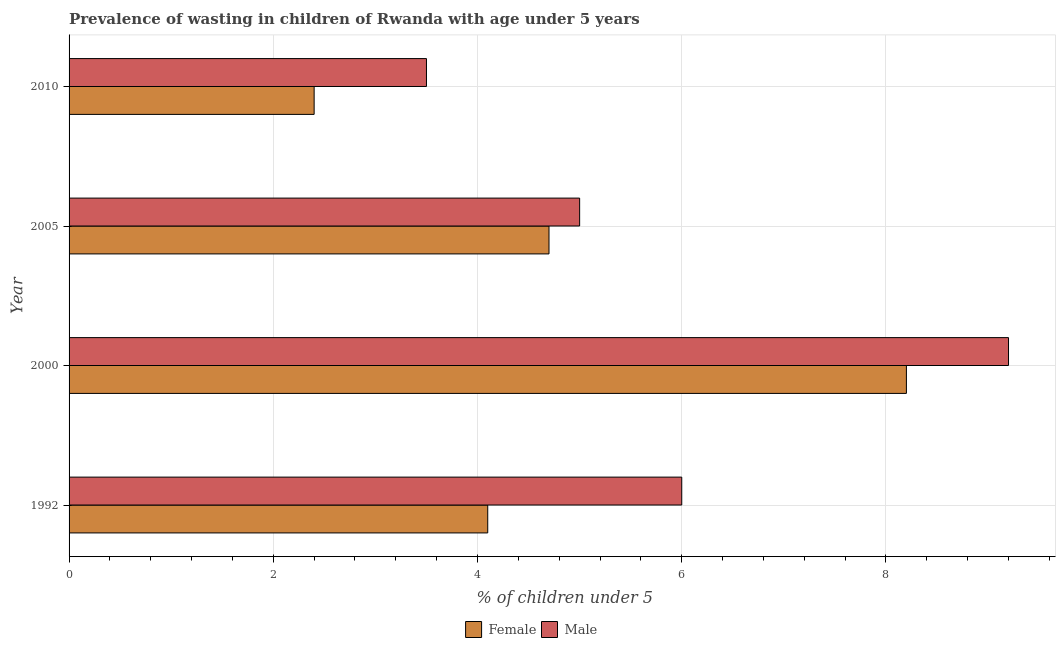How many groups of bars are there?
Your answer should be compact. 4. Are the number of bars on each tick of the Y-axis equal?
Offer a terse response. Yes. How many bars are there on the 1st tick from the top?
Give a very brief answer. 2. What is the percentage of undernourished female children in 2010?
Offer a terse response. 2.4. Across all years, what is the maximum percentage of undernourished female children?
Keep it short and to the point. 8.2. Across all years, what is the minimum percentage of undernourished male children?
Offer a terse response. 3.5. What is the total percentage of undernourished male children in the graph?
Offer a terse response. 23.7. What is the difference between the percentage of undernourished female children in 2005 and the percentage of undernourished male children in 1992?
Keep it short and to the point. -1.3. What is the average percentage of undernourished female children per year?
Offer a very short reply. 4.85. In how many years, is the percentage of undernourished male children greater than 7.6 %?
Your answer should be compact. 1. Is the percentage of undernourished female children in 1992 less than that in 2010?
Provide a short and direct response. No. Is the difference between the percentage of undernourished female children in 2000 and 2010 greater than the difference between the percentage of undernourished male children in 2000 and 2010?
Your answer should be compact. Yes. What is the difference between the highest and the second highest percentage of undernourished female children?
Provide a succinct answer. 3.5. What is the difference between the highest and the lowest percentage of undernourished female children?
Provide a succinct answer. 5.8. Is the sum of the percentage of undernourished female children in 2000 and 2010 greater than the maximum percentage of undernourished male children across all years?
Your answer should be compact. Yes. What does the 1st bar from the top in 1992 represents?
Offer a terse response. Male. How many bars are there?
Provide a short and direct response. 8. Are all the bars in the graph horizontal?
Provide a short and direct response. Yes. How many years are there in the graph?
Give a very brief answer. 4. Does the graph contain any zero values?
Your answer should be very brief. No. Does the graph contain grids?
Make the answer very short. Yes. Where does the legend appear in the graph?
Provide a succinct answer. Bottom center. How are the legend labels stacked?
Offer a very short reply. Horizontal. What is the title of the graph?
Provide a succinct answer. Prevalence of wasting in children of Rwanda with age under 5 years. Does "Travel services" appear as one of the legend labels in the graph?
Provide a short and direct response. No. What is the label or title of the X-axis?
Offer a very short reply.  % of children under 5. What is the  % of children under 5 in Female in 1992?
Make the answer very short. 4.1. What is the  % of children under 5 of Female in 2000?
Make the answer very short. 8.2. What is the  % of children under 5 in Male in 2000?
Provide a succinct answer. 9.2. What is the  % of children under 5 in Female in 2005?
Your answer should be very brief. 4.7. What is the  % of children under 5 in Male in 2005?
Provide a succinct answer. 5. What is the  % of children under 5 in Female in 2010?
Make the answer very short. 2.4. Across all years, what is the maximum  % of children under 5 of Female?
Your answer should be compact. 8.2. Across all years, what is the maximum  % of children under 5 of Male?
Your answer should be compact. 9.2. Across all years, what is the minimum  % of children under 5 in Female?
Provide a succinct answer. 2.4. What is the total  % of children under 5 in Female in the graph?
Your answer should be compact. 19.4. What is the total  % of children under 5 in Male in the graph?
Provide a succinct answer. 23.7. What is the difference between the  % of children under 5 of Female in 1992 and that in 2005?
Provide a succinct answer. -0.6. What is the difference between the  % of children under 5 of Male in 1992 and that in 2010?
Offer a terse response. 2.5. What is the difference between the  % of children under 5 in Female in 2000 and that in 2005?
Provide a short and direct response. 3.5. What is the difference between the  % of children under 5 of Male in 2000 and that in 2005?
Keep it short and to the point. 4.2. What is the difference between the  % of children under 5 of Male in 2000 and that in 2010?
Keep it short and to the point. 5.7. What is the difference between the  % of children under 5 in Female in 2005 and that in 2010?
Your response must be concise. 2.3. What is the difference between the  % of children under 5 of Male in 2005 and that in 2010?
Make the answer very short. 1.5. What is the difference between the  % of children under 5 of Female in 1992 and the  % of children under 5 of Male in 2005?
Your answer should be very brief. -0.9. What is the difference between the  % of children under 5 of Female in 1992 and the  % of children under 5 of Male in 2010?
Offer a terse response. 0.6. What is the difference between the  % of children under 5 of Female in 2000 and the  % of children under 5 of Male in 2010?
Offer a terse response. 4.7. What is the difference between the  % of children under 5 of Female in 2005 and the  % of children under 5 of Male in 2010?
Your response must be concise. 1.2. What is the average  % of children under 5 in Female per year?
Your answer should be very brief. 4.85. What is the average  % of children under 5 in Male per year?
Give a very brief answer. 5.92. In the year 1992, what is the difference between the  % of children under 5 of Female and  % of children under 5 of Male?
Ensure brevity in your answer.  -1.9. In the year 2000, what is the difference between the  % of children under 5 in Female and  % of children under 5 in Male?
Offer a very short reply. -1. In the year 2005, what is the difference between the  % of children under 5 of Female and  % of children under 5 of Male?
Provide a succinct answer. -0.3. What is the ratio of the  % of children under 5 of Female in 1992 to that in 2000?
Ensure brevity in your answer.  0.5. What is the ratio of the  % of children under 5 in Male in 1992 to that in 2000?
Your answer should be very brief. 0.65. What is the ratio of the  % of children under 5 in Female in 1992 to that in 2005?
Your answer should be very brief. 0.87. What is the ratio of the  % of children under 5 of Male in 1992 to that in 2005?
Provide a succinct answer. 1.2. What is the ratio of the  % of children under 5 in Female in 1992 to that in 2010?
Provide a short and direct response. 1.71. What is the ratio of the  % of children under 5 of Male in 1992 to that in 2010?
Offer a very short reply. 1.71. What is the ratio of the  % of children under 5 in Female in 2000 to that in 2005?
Make the answer very short. 1.74. What is the ratio of the  % of children under 5 in Male in 2000 to that in 2005?
Ensure brevity in your answer.  1.84. What is the ratio of the  % of children under 5 of Female in 2000 to that in 2010?
Keep it short and to the point. 3.42. What is the ratio of the  % of children under 5 of Male in 2000 to that in 2010?
Make the answer very short. 2.63. What is the ratio of the  % of children under 5 in Female in 2005 to that in 2010?
Your answer should be compact. 1.96. What is the ratio of the  % of children under 5 of Male in 2005 to that in 2010?
Provide a short and direct response. 1.43. What is the difference between the highest and the lowest  % of children under 5 in Female?
Ensure brevity in your answer.  5.8. 